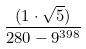Convert formula to latex. <formula><loc_0><loc_0><loc_500><loc_500>\frac { ( 1 \cdot \sqrt { 5 } ) } { 2 8 0 - 9 ^ { 3 9 8 } }</formula> 